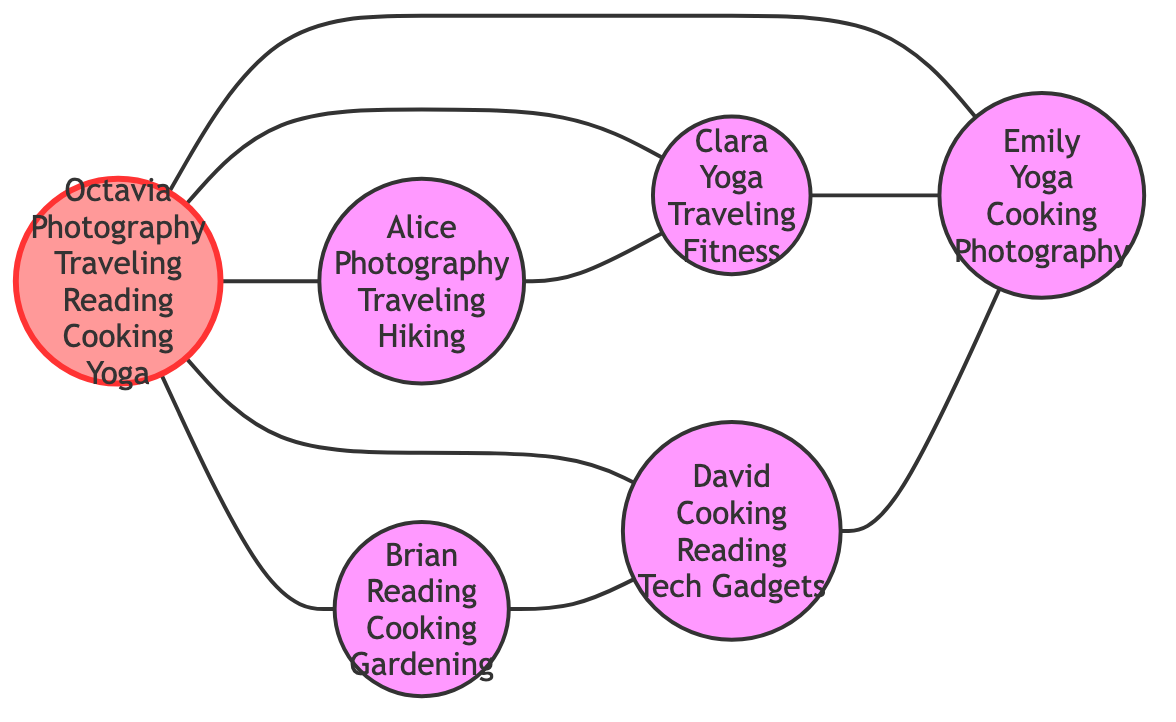What is Octavia's first interest? The diagram lists Octavia's interests as Photography, Traveling, Reading, Cooking, and Yoga. The first one listed is Photography.
Answer: Photography How many people does Octavia share interests with? The diagram shows five edges connected to Octavia from Alice, Brian, Clara, David, and Emily, indicating she shares interests with five people.
Answer: 5 Which interest do both Octavia and Emily share? The list of interests for Octavia includes Photography, Traveling, Reading, Cooking, and Yoga. For Emily, the interests are Yoga, Cooking, and Photography. The common interests between them are Cooking and Photography, but Cooking comes first.
Answer: Cooking Who has an interest in Gardening? Looking at the nodes, only Brian has Gardening listed among his interests, showing that he is the sole person interested in this activity, as none of the other nodes mention Gardening.
Answer: Brian How many edges are connected to David? The diagram indicates that David is connected to Emily and Brian, forming two edges in the graph that represent shared interests, which means he's involved in two connections.
Answer: 2 Which two people share interests and have a direct connection? From the edges, we can see multiple connections. For example, Alice and Clara share an interest and are directly connected in the graph, shown by an edge between them.
Answer: Alice and Clara What is the total number of nodes in the graph? The nodes listed in the diagram are Octavia, Alice, Brian, Clara, David, and Emily, making a total of six distinct individuals present in the social circle graph shown.
Answer: 6 Which person shares interests with the most others? By analyzing the edges, we can see that Octavia is connected to five people. No other individual shares interests with as many people as she does, making her the most connected person in the graph.
Answer: Octavia Which interest is unique to Brian? Brian's interests include Reading, Cooking, and Gardening, and among these, Gardening is not mentioned by any other individual in the graph, making it uniquely his.
Answer: Gardening 